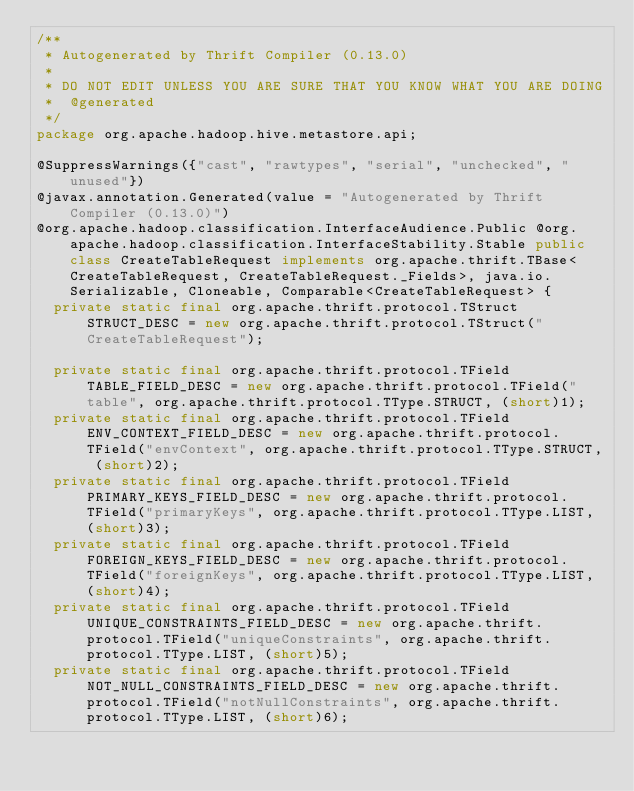Convert code to text. <code><loc_0><loc_0><loc_500><loc_500><_Java_>/**
 * Autogenerated by Thrift Compiler (0.13.0)
 *
 * DO NOT EDIT UNLESS YOU ARE SURE THAT YOU KNOW WHAT YOU ARE DOING
 *  @generated
 */
package org.apache.hadoop.hive.metastore.api;

@SuppressWarnings({"cast", "rawtypes", "serial", "unchecked", "unused"})
@javax.annotation.Generated(value = "Autogenerated by Thrift Compiler (0.13.0)")
@org.apache.hadoop.classification.InterfaceAudience.Public @org.apache.hadoop.classification.InterfaceStability.Stable public class CreateTableRequest implements org.apache.thrift.TBase<CreateTableRequest, CreateTableRequest._Fields>, java.io.Serializable, Cloneable, Comparable<CreateTableRequest> {
  private static final org.apache.thrift.protocol.TStruct STRUCT_DESC = new org.apache.thrift.protocol.TStruct("CreateTableRequest");

  private static final org.apache.thrift.protocol.TField TABLE_FIELD_DESC = new org.apache.thrift.protocol.TField("table", org.apache.thrift.protocol.TType.STRUCT, (short)1);
  private static final org.apache.thrift.protocol.TField ENV_CONTEXT_FIELD_DESC = new org.apache.thrift.protocol.TField("envContext", org.apache.thrift.protocol.TType.STRUCT, (short)2);
  private static final org.apache.thrift.protocol.TField PRIMARY_KEYS_FIELD_DESC = new org.apache.thrift.protocol.TField("primaryKeys", org.apache.thrift.protocol.TType.LIST, (short)3);
  private static final org.apache.thrift.protocol.TField FOREIGN_KEYS_FIELD_DESC = new org.apache.thrift.protocol.TField("foreignKeys", org.apache.thrift.protocol.TType.LIST, (short)4);
  private static final org.apache.thrift.protocol.TField UNIQUE_CONSTRAINTS_FIELD_DESC = new org.apache.thrift.protocol.TField("uniqueConstraints", org.apache.thrift.protocol.TType.LIST, (short)5);
  private static final org.apache.thrift.protocol.TField NOT_NULL_CONSTRAINTS_FIELD_DESC = new org.apache.thrift.protocol.TField("notNullConstraints", org.apache.thrift.protocol.TType.LIST, (short)6);</code> 